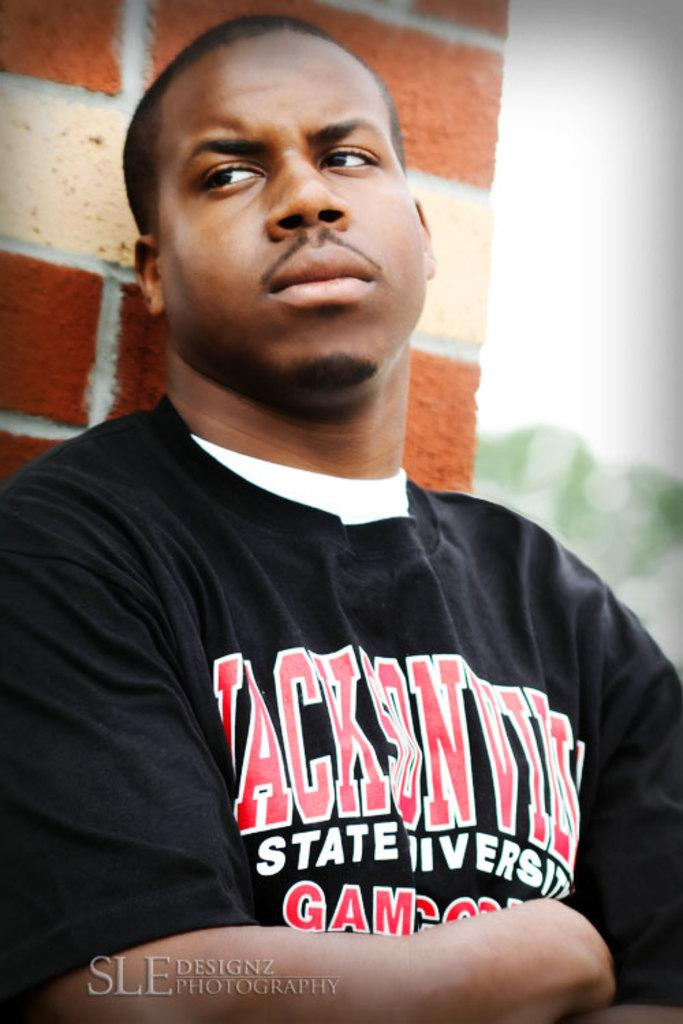<image>
Render a clear and concise summary of the photo. a man that has a shirt that says Jacksonville on it 